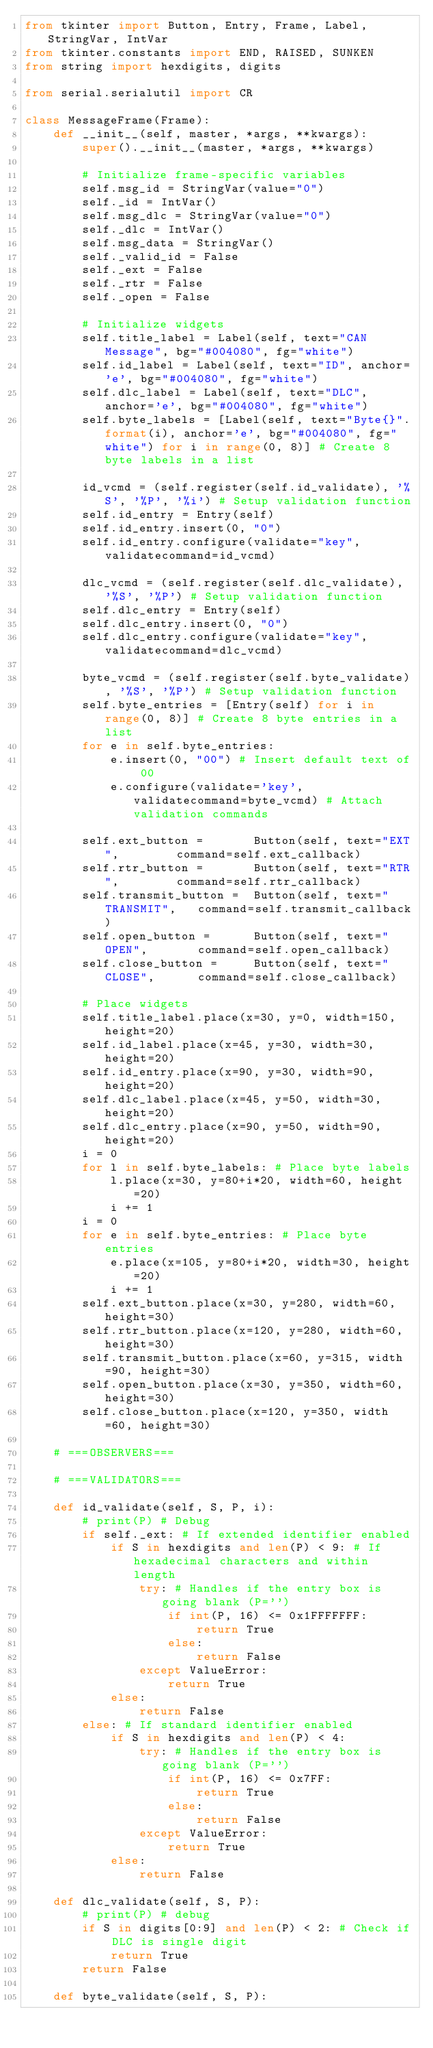<code> <loc_0><loc_0><loc_500><loc_500><_Python_>from tkinter import Button, Entry, Frame, Label, StringVar, IntVar
from tkinter.constants import END, RAISED, SUNKEN
from string import hexdigits, digits

from serial.serialutil import CR

class MessageFrame(Frame):
    def __init__(self, master, *args, **kwargs):
        super().__init__(master, *args, **kwargs)

        # Initialize frame-specific variables
        self.msg_id = StringVar(value="0")
        self._id = IntVar()
        self.msg_dlc = StringVar(value="0")
        self._dlc = IntVar()
        self.msg_data = StringVar()
        self._valid_id = False
        self._ext = False
        self._rtr = False
        self._open = False

        # Initialize widgets
        self.title_label = Label(self, text="CAN Message", bg="#004080", fg="white")
        self.id_label = Label(self, text="ID", anchor='e', bg="#004080", fg="white")
        self.dlc_label = Label(self, text="DLC", anchor='e', bg="#004080", fg="white")
        self.byte_labels = [Label(self, text="Byte{}".format(i), anchor='e', bg="#004080", fg="white") for i in range(0, 8)] # Create 8 byte labels in a list

        id_vcmd = (self.register(self.id_validate), '%S', '%P', '%i') # Setup validation function
        self.id_entry = Entry(self)
        self.id_entry.insert(0, "0")
        self.id_entry.configure(validate="key", validatecommand=id_vcmd)

        dlc_vcmd = (self.register(self.dlc_validate), '%S', '%P') # Setup validation function
        self.dlc_entry = Entry(self)
        self.dlc_entry.insert(0, "0")
        self.dlc_entry.configure(validate="key", validatecommand=dlc_vcmd)

        byte_vcmd = (self.register(self.byte_validate), '%S', '%P') # Setup validation function
        self.byte_entries = [Entry(self) for i in range(0, 8)] # Create 8 byte entries in a list
        for e in self.byte_entries:
            e.insert(0, "00") # Insert default text of 00
            e.configure(validate='key', validatecommand=byte_vcmd) # Attach validation commands

        self.ext_button =       Button(self, text="EXT",        command=self.ext_callback)
        self.rtr_button =       Button(self, text="RTR",        command=self.rtr_callback)
        self.transmit_button =  Button(self, text="TRANSMIT",   command=self.transmit_callback)
        self.open_button =      Button(self, text="OPEN",       command=self.open_callback)
        self.close_button =     Button(self, text="CLOSE",      command=self.close_callback)

        # Place widgets
        self.title_label.place(x=30, y=0, width=150, height=20)
        self.id_label.place(x=45, y=30, width=30, height=20)
        self.id_entry.place(x=90, y=30, width=90, height=20)
        self.dlc_label.place(x=45, y=50, width=30, height=20)
        self.dlc_entry.place(x=90, y=50, width=90, height=20)
        i = 0
        for l in self.byte_labels: # Place byte labels
            l.place(x=30, y=80+i*20, width=60, height=20)
            i += 1
        i = 0
        for e in self.byte_entries: # Place byte entries
            e.place(x=105, y=80+i*20, width=30, height=20)
            i += 1
        self.ext_button.place(x=30, y=280, width=60, height=30)
        self.rtr_button.place(x=120, y=280, width=60, height=30)
        self.transmit_button.place(x=60, y=315, width=90, height=30)
        self.open_button.place(x=30, y=350, width=60, height=30)
        self.close_button.place(x=120, y=350, width=60, height=30)

    # ===OBSERVERS===

    # ===VALIDATORS===

    def id_validate(self, S, P, i):
        # print(P) # Debug
        if self._ext: # If extended identifier enabled
            if S in hexdigits and len(P) < 9: # If hexadecimal characters and within length
                try: # Handles if the entry box is going blank (P='')
                    if int(P, 16) <= 0x1FFFFFFF:
                        return True
                    else:
                        return False
                except ValueError:
                    return True
            else:
                return False
        else: # If standard identifier enabled
            if S in hexdigits and len(P) < 4:
                try: # Handles if the entry box is going blank (P='')
                    if int(P, 16) <= 0x7FF:
                        return True
                    else:
                        return False
                except ValueError:
                    return True
            else:
                return False

    def dlc_validate(self, S, P):
        # print(P) # debug
        if S in digits[0:9] and len(P) < 2: # Check if DLC is single digit
            return True
        return False

    def byte_validate(self, S, P):</code> 